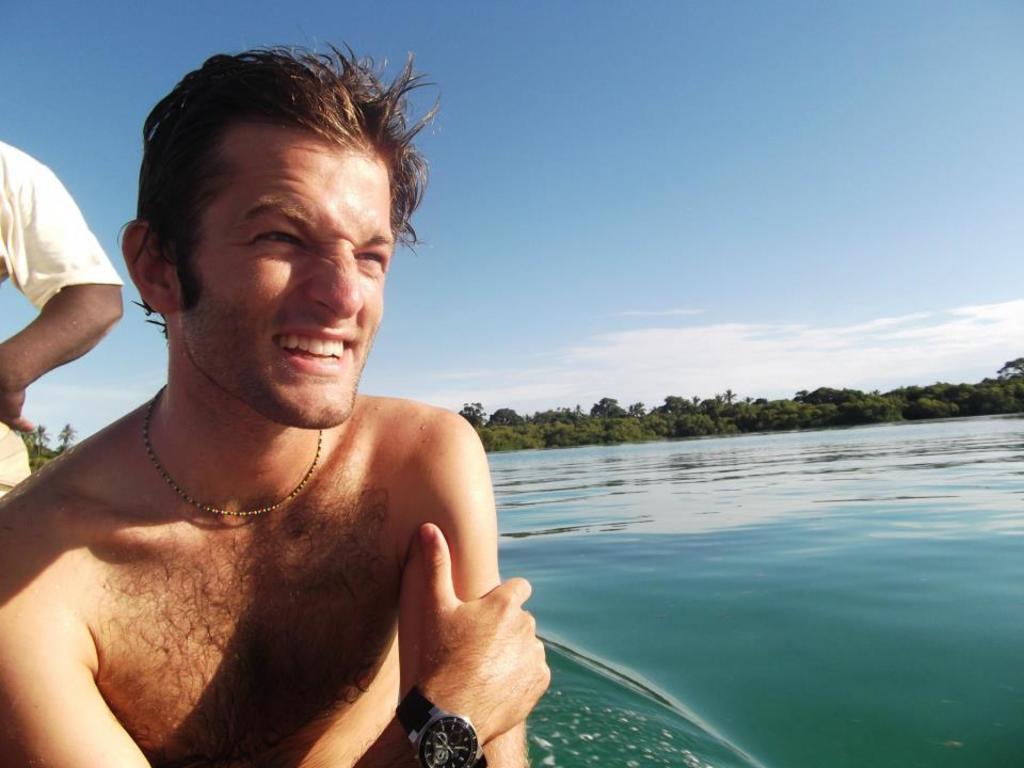Describe this image in one or two sentences. In this image we can see a man is sitting, and smiling, at back here a person is standing, here is the water, here are the trees, at above here is the sky. 